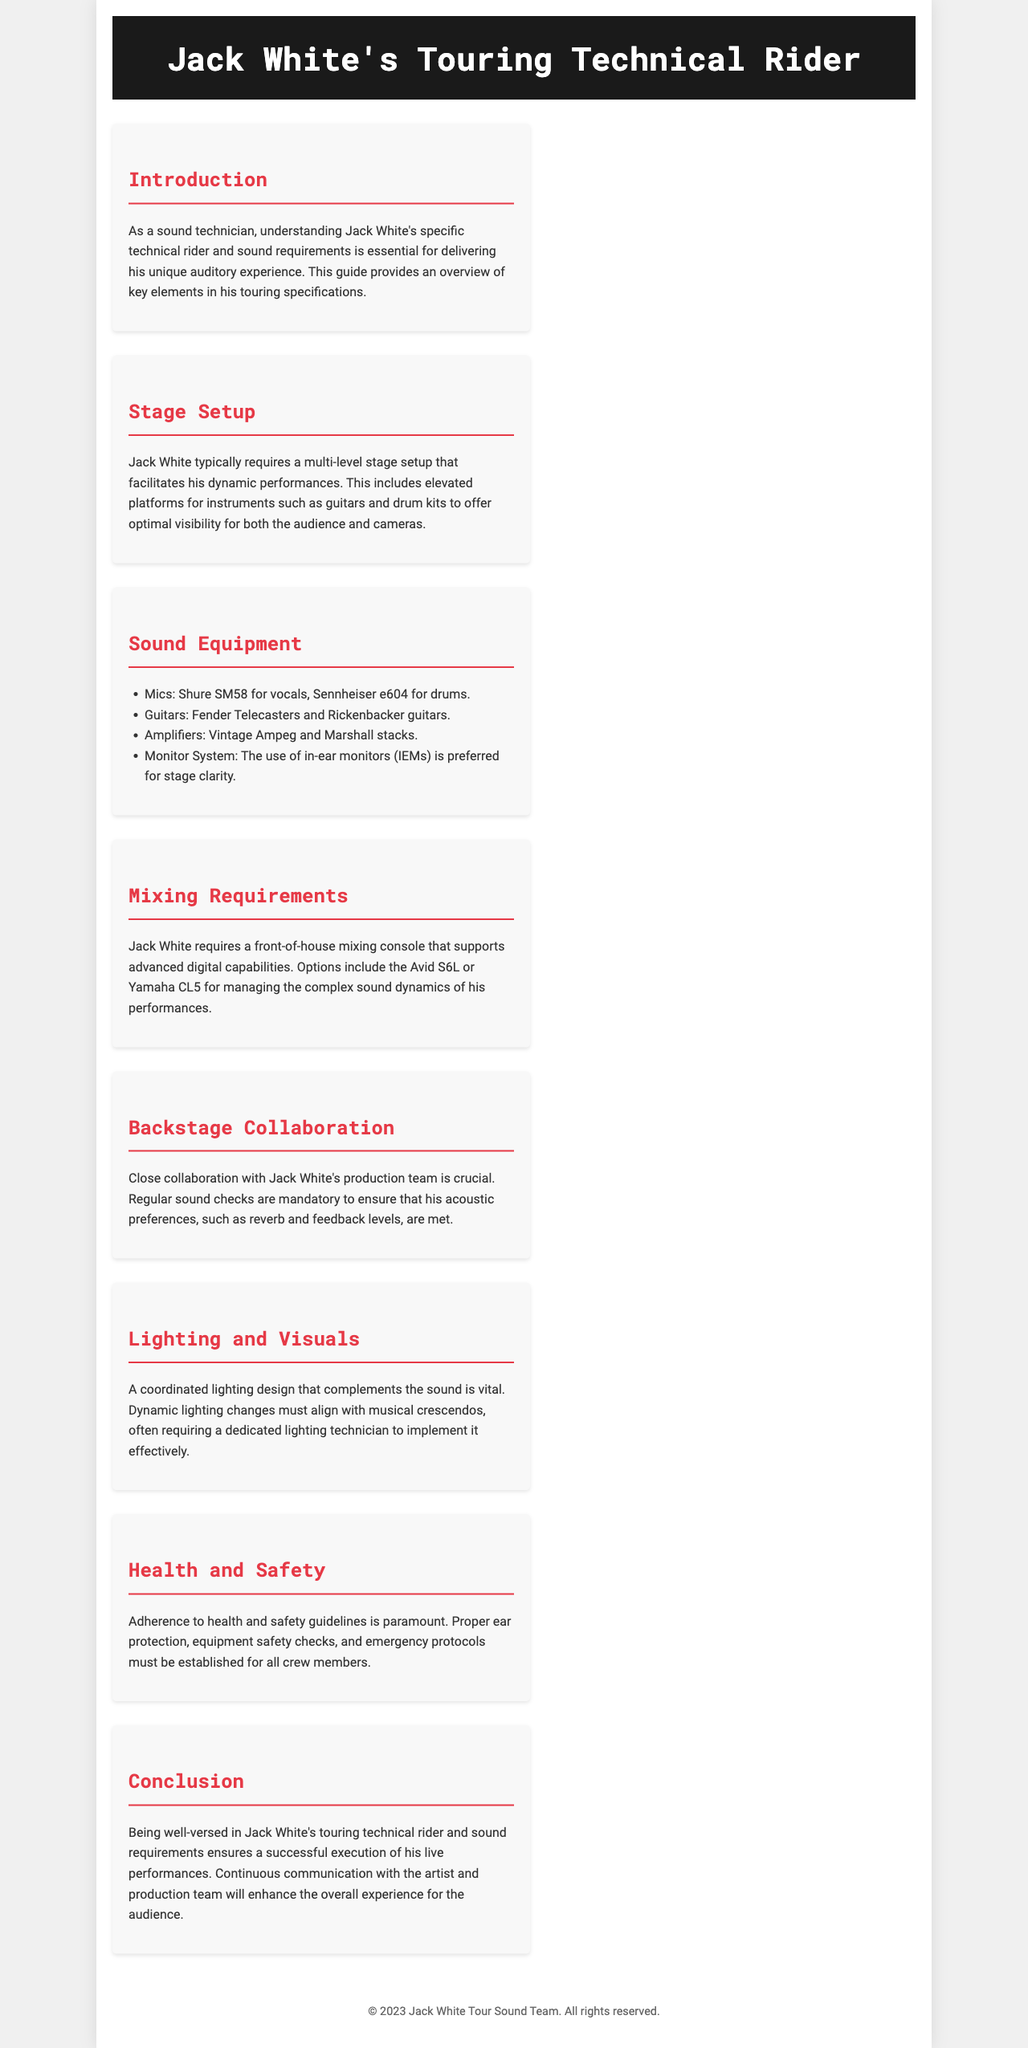What is the title of the document? The title is specified in the header section of the document.
Answer: Jack White's Touring Technical Rider What is Jack White's preferred microphone for vocals? The specific microphone is listed under the sound equipment section.
Answer: Shure SM58 Which mixing console options are mentioned for Jack White's performances? Both console options can be found in the mixing requirements section of the document.
Answer: Avid S6L or Yamaha CL5 What is the primary focus of the introduction section? The introduction outlines the importance of understanding Jack White's technical rider.
Answer: Importance for delivering auditory experience How does Jack White prefer to monitor sound on stage? The monitoring preference is detailed in the sound equipment section.
Answer: In-ear monitors (IEMs) What type of stage setup does Jack White typically require? The stage setup specifics can be found in the corresponding section of the document.
Answer: Multi-level stage setup What is emphasized regarding backstage collaboration? The collaboration aspect is highlighted in the backstage collaboration section.
Answer: Close collaboration with production team What is a key health and safety requirement mentioned? Health and safety guidelines are specified in that section of the document.
Answer: Proper ear protection 